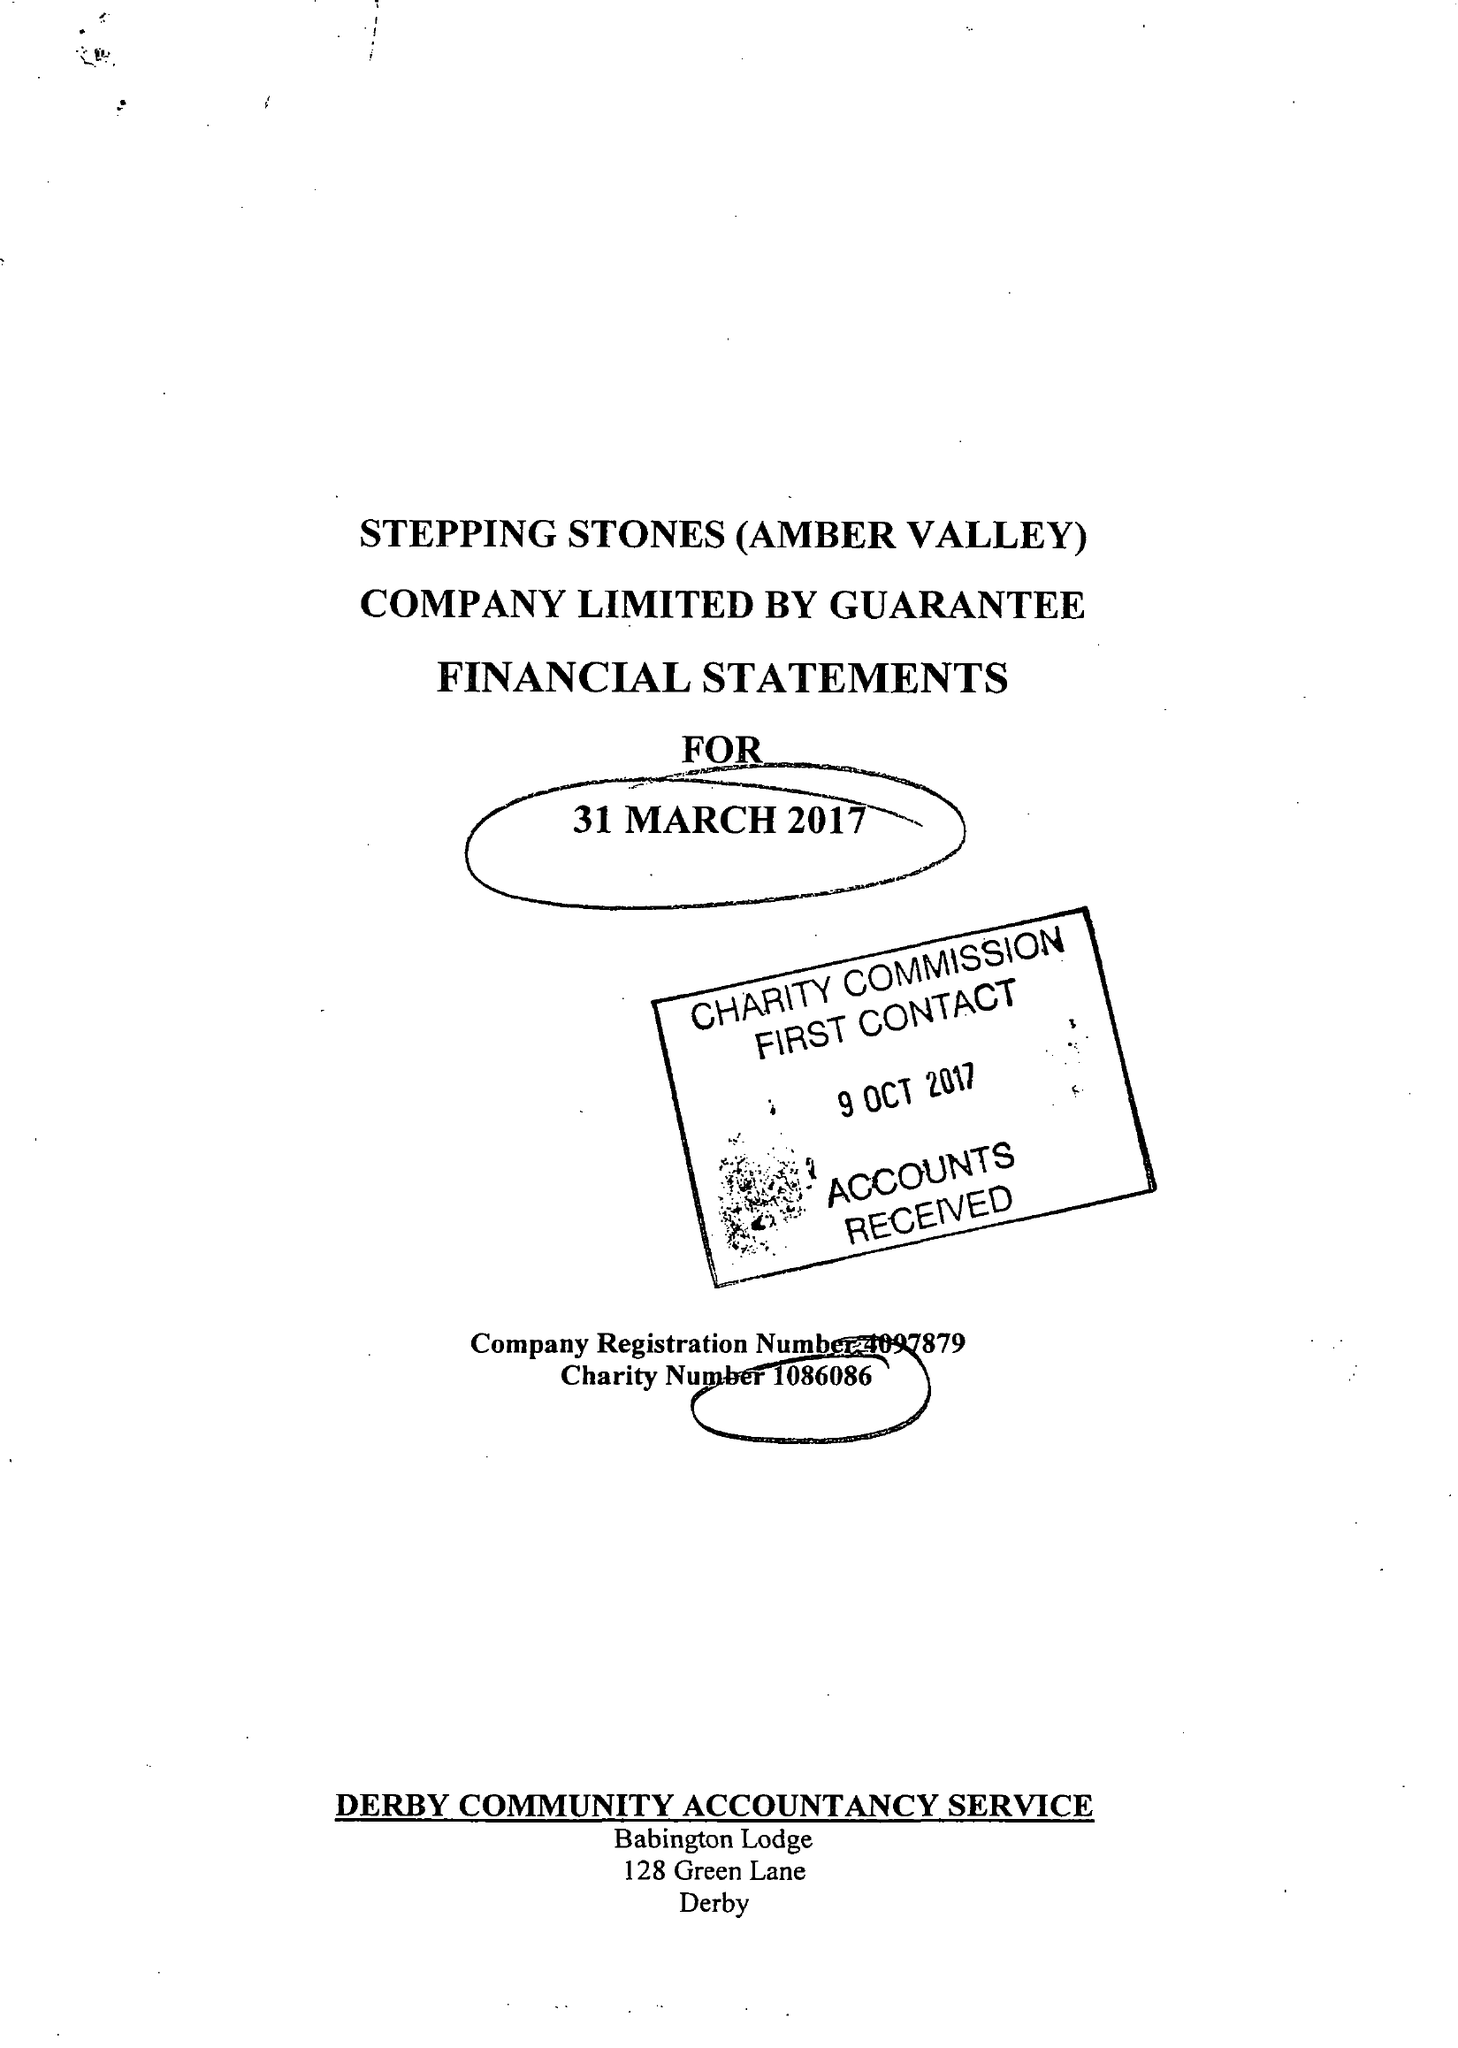What is the value for the address__post_town?
Answer the question using a single word or phrase. NOTTINGHAM 